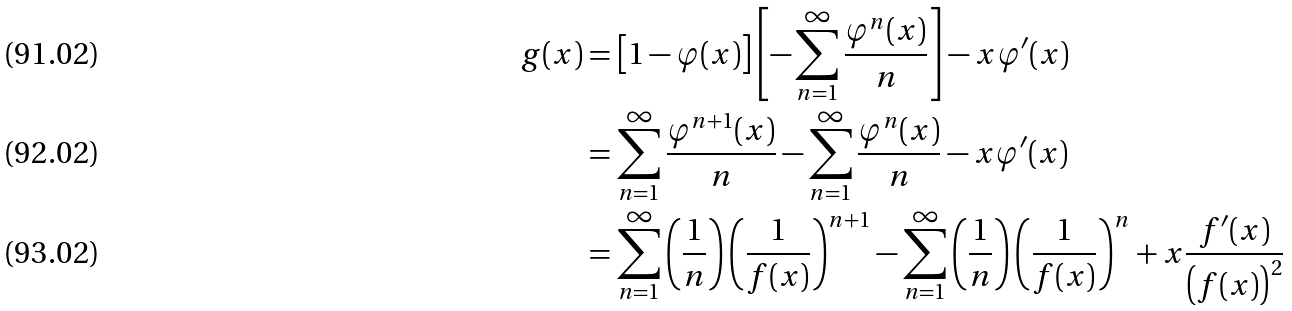<formula> <loc_0><loc_0><loc_500><loc_500>g ( x ) & = \left [ 1 - \varphi ( x ) \right ] \left [ - \sum _ { n = 1 } ^ { \infty } \frac { \varphi ^ { n } ( x ) } { n } \right ] - x \varphi ^ { \prime } ( x ) \\ & = \sum _ { n = 1 } ^ { \infty } \frac { \varphi ^ { n + 1 } ( x ) } { n } - \sum _ { n = 1 } ^ { \infty } \frac { \varphi ^ { n } ( x ) } { n } - x \varphi ^ { \prime } ( x ) \\ & = \sum _ { n = 1 } ^ { \infty } \left ( \frac { 1 } { n } \right ) \left ( \frac { 1 } { f ( x ) } \right ) ^ { n + 1 } - \sum _ { n = 1 } ^ { \infty } \left ( \frac { 1 } { n } \right ) \left ( \frac { 1 } { f ( x ) } \right ) ^ { n } + x \frac { f ^ { \prime } ( x ) } { \left ( f ( x ) \right ) ^ { 2 } }</formula> 